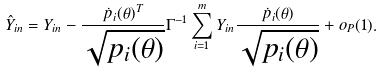Convert formula to latex. <formula><loc_0><loc_0><loc_500><loc_500>\hat { Y } _ { i n } = Y _ { i n } - \frac { \dot { p } _ { i } ( \theta ) ^ { T } } { \sqrt { p _ { i } ( \theta ) } } \Gamma ^ { - 1 } \sum _ { i = 1 } ^ { m } Y _ { i n } \frac { \dot { p } _ { i } ( \theta ) } { \sqrt { p _ { i } ( \theta ) } } + o _ { P } ( 1 ) .</formula> 